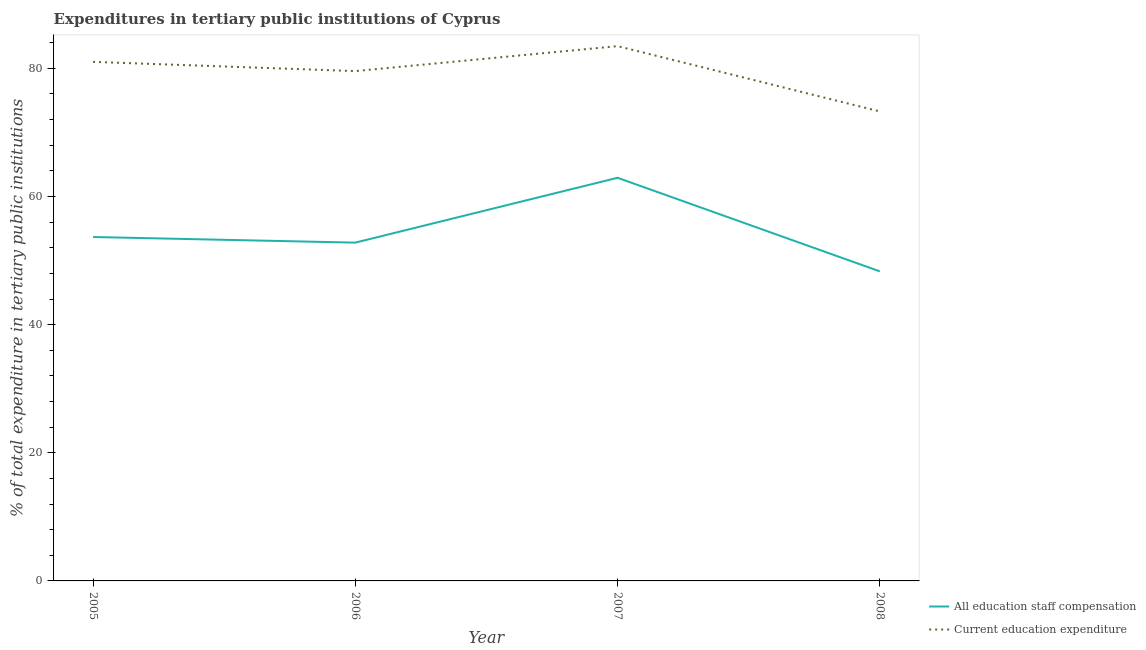What is the expenditure in education in 2008?
Provide a short and direct response. 73.28. Across all years, what is the maximum expenditure in education?
Make the answer very short. 83.47. Across all years, what is the minimum expenditure in education?
Your answer should be compact. 73.28. What is the total expenditure in staff compensation in the graph?
Your response must be concise. 217.71. What is the difference between the expenditure in staff compensation in 2007 and that in 2008?
Offer a terse response. 14.61. What is the difference between the expenditure in staff compensation in 2008 and the expenditure in education in 2005?
Provide a succinct answer. -32.7. What is the average expenditure in staff compensation per year?
Offer a terse response. 54.43. In the year 2008, what is the difference between the expenditure in education and expenditure in staff compensation?
Give a very brief answer. 24.97. What is the ratio of the expenditure in education in 2006 to that in 2007?
Make the answer very short. 0.95. Is the expenditure in staff compensation in 2005 less than that in 2008?
Your response must be concise. No. What is the difference between the highest and the second highest expenditure in education?
Make the answer very short. 2.45. What is the difference between the highest and the lowest expenditure in education?
Offer a very short reply. 10.19. In how many years, is the expenditure in staff compensation greater than the average expenditure in staff compensation taken over all years?
Offer a very short reply. 1. Is the sum of the expenditure in staff compensation in 2005 and 2006 greater than the maximum expenditure in education across all years?
Ensure brevity in your answer.  Yes. Is the expenditure in staff compensation strictly greater than the expenditure in education over the years?
Your answer should be compact. No. Is the expenditure in staff compensation strictly less than the expenditure in education over the years?
Your answer should be very brief. Yes. How many lines are there?
Offer a terse response. 2. How many years are there in the graph?
Provide a short and direct response. 4. What is the difference between two consecutive major ticks on the Y-axis?
Keep it short and to the point. 20. Are the values on the major ticks of Y-axis written in scientific E-notation?
Your response must be concise. No. How are the legend labels stacked?
Provide a succinct answer. Vertical. What is the title of the graph?
Give a very brief answer. Expenditures in tertiary public institutions of Cyprus. Does "Ages 15-24" appear as one of the legend labels in the graph?
Ensure brevity in your answer.  No. What is the label or title of the X-axis?
Provide a succinct answer. Year. What is the label or title of the Y-axis?
Ensure brevity in your answer.  % of total expenditure in tertiary public institutions. What is the % of total expenditure in tertiary public institutions of All education staff compensation in 2005?
Ensure brevity in your answer.  53.68. What is the % of total expenditure in tertiary public institutions in Current education expenditure in 2005?
Offer a very short reply. 81.01. What is the % of total expenditure in tertiary public institutions in All education staff compensation in 2006?
Ensure brevity in your answer.  52.8. What is the % of total expenditure in tertiary public institutions of Current education expenditure in 2006?
Offer a very short reply. 79.57. What is the % of total expenditure in tertiary public institutions of All education staff compensation in 2007?
Give a very brief answer. 62.92. What is the % of total expenditure in tertiary public institutions in Current education expenditure in 2007?
Your answer should be very brief. 83.47. What is the % of total expenditure in tertiary public institutions in All education staff compensation in 2008?
Ensure brevity in your answer.  48.31. What is the % of total expenditure in tertiary public institutions of Current education expenditure in 2008?
Offer a terse response. 73.28. Across all years, what is the maximum % of total expenditure in tertiary public institutions in All education staff compensation?
Give a very brief answer. 62.92. Across all years, what is the maximum % of total expenditure in tertiary public institutions in Current education expenditure?
Offer a terse response. 83.47. Across all years, what is the minimum % of total expenditure in tertiary public institutions of All education staff compensation?
Ensure brevity in your answer.  48.31. Across all years, what is the minimum % of total expenditure in tertiary public institutions in Current education expenditure?
Make the answer very short. 73.28. What is the total % of total expenditure in tertiary public institutions of All education staff compensation in the graph?
Ensure brevity in your answer.  217.71. What is the total % of total expenditure in tertiary public institutions in Current education expenditure in the graph?
Offer a very short reply. 317.33. What is the difference between the % of total expenditure in tertiary public institutions of All education staff compensation in 2005 and that in 2006?
Offer a very short reply. 0.88. What is the difference between the % of total expenditure in tertiary public institutions of Current education expenditure in 2005 and that in 2006?
Offer a terse response. 1.44. What is the difference between the % of total expenditure in tertiary public institutions in All education staff compensation in 2005 and that in 2007?
Provide a succinct answer. -9.24. What is the difference between the % of total expenditure in tertiary public institutions in Current education expenditure in 2005 and that in 2007?
Ensure brevity in your answer.  -2.45. What is the difference between the % of total expenditure in tertiary public institutions of All education staff compensation in 2005 and that in 2008?
Ensure brevity in your answer.  5.36. What is the difference between the % of total expenditure in tertiary public institutions of Current education expenditure in 2005 and that in 2008?
Offer a very short reply. 7.73. What is the difference between the % of total expenditure in tertiary public institutions of All education staff compensation in 2006 and that in 2007?
Make the answer very short. -10.12. What is the difference between the % of total expenditure in tertiary public institutions in Current education expenditure in 2006 and that in 2007?
Give a very brief answer. -3.89. What is the difference between the % of total expenditure in tertiary public institutions in All education staff compensation in 2006 and that in 2008?
Provide a short and direct response. 4.49. What is the difference between the % of total expenditure in tertiary public institutions in Current education expenditure in 2006 and that in 2008?
Keep it short and to the point. 6.29. What is the difference between the % of total expenditure in tertiary public institutions of All education staff compensation in 2007 and that in 2008?
Provide a short and direct response. 14.61. What is the difference between the % of total expenditure in tertiary public institutions in Current education expenditure in 2007 and that in 2008?
Your answer should be very brief. 10.19. What is the difference between the % of total expenditure in tertiary public institutions in All education staff compensation in 2005 and the % of total expenditure in tertiary public institutions in Current education expenditure in 2006?
Your response must be concise. -25.89. What is the difference between the % of total expenditure in tertiary public institutions of All education staff compensation in 2005 and the % of total expenditure in tertiary public institutions of Current education expenditure in 2007?
Your response must be concise. -29.79. What is the difference between the % of total expenditure in tertiary public institutions of All education staff compensation in 2005 and the % of total expenditure in tertiary public institutions of Current education expenditure in 2008?
Offer a very short reply. -19.6. What is the difference between the % of total expenditure in tertiary public institutions of All education staff compensation in 2006 and the % of total expenditure in tertiary public institutions of Current education expenditure in 2007?
Your answer should be compact. -30.67. What is the difference between the % of total expenditure in tertiary public institutions of All education staff compensation in 2006 and the % of total expenditure in tertiary public institutions of Current education expenditure in 2008?
Make the answer very short. -20.48. What is the difference between the % of total expenditure in tertiary public institutions in All education staff compensation in 2007 and the % of total expenditure in tertiary public institutions in Current education expenditure in 2008?
Ensure brevity in your answer.  -10.36. What is the average % of total expenditure in tertiary public institutions in All education staff compensation per year?
Offer a terse response. 54.43. What is the average % of total expenditure in tertiary public institutions of Current education expenditure per year?
Your answer should be very brief. 79.33. In the year 2005, what is the difference between the % of total expenditure in tertiary public institutions of All education staff compensation and % of total expenditure in tertiary public institutions of Current education expenditure?
Keep it short and to the point. -27.34. In the year 2006, what is the difference between the % of total expenditure in tertiary public institutions in All education staff compensation and % of total expenditure in tertiary public institutions in Current education expenditure?
Provide a succinct answer. -26.77. In the year 2007, what is the difference between the % of total expenditure in tertiary public institutions of All education staff compensation and % of total expenditure in tertiary public institutions of Current education expenditure?
Make the answer very short. -20.55. In the year 2008, what is the difference between the % of total expenditure in tertiary public institutions of All education staff compensation and % of total expenditure in tertiary public institutions of Current education expenditure?
Offer a very short reply. -24.97. What is the ratio of the % of total expenditure in tertiary public institutions in All education staff compensation in 2005 to that in 2006?
Ensure brevity in your answer.  1.02. What is the ratio of the % of total expenditure in tertiary public institutions in Current education expenditure in 2005 to that in 2006?
Offer a terse response. 1.02. What is the ratio of the % of total expenditure in tertiary public institutions in All education staff compensation in 2005 to that in 2007?
Ensure brevity in your answer.  0.85. What is the ratio of the % of total expenditure in tertiary public institutions of Current education expenditure in 2005 to that in 2007?
Provide a short and direct response. 0.97. What is the ratio of the % of total expenditure in tertiary public institutions of All education staff compensation in 2005 to that in 2008?
Provide a succinct answer. 1.11. What is the ratio of the % of total expenditure in tertiary public institutions in Current education expenditure in 2005 to that in 2008?
Offer a terse response. 1.11. What is the ratio of the % of total expenditure in tertiary public institutions of All education staff compensation in 2006 to that in 2007?
Provide a succinct answer. 0.84. What is the ratio of the % of total expenditure in tertiary public institutions of Current education expenditure in 2006 to that in 2007?
Offer a terse response. 0.95. What is the ratio of the % of total expenditure in tertiary public institutions in All education staff compensation in 2006 to that in 2008?
Offer a very short reply. 1.09. What is the ratio of the % of total expenditure in tertiary public institutions in Current education expenditure in 2006 to that in 2008?
Your answer should be compact. 1.09. What is the ratio of the % of total expenditure in tertiary public institutions in All education staff compensation in 2007 to that in 2008?
Keep it short and to the point. 1.3. What is the ratio of the % of total expenditure in tertiary public institutions of Current education expenditure in 2007 to that in 2008?
Your answer should be very brief. 1.14. What is the difference between the highest and the second highest % of total expenditure in tertiary public institutions of All education staff compensation?
Your response must be concise. 9.24. What is the difference between the highest and the second highest % of total expenditure in tertiary public institutions in Current education expenditure?
Provide a succinct answer. 2.45. What is the difference between the highest and the lowest % of total expenditure in tertiary public institutions in All education staff compensation?
Keep it short and to the point. 14.61. What is the difference between the highest and the lowest % of total expenditure in tertiary public institutions in Current education expenditure?
Provide a succinct answer. 10.19. 